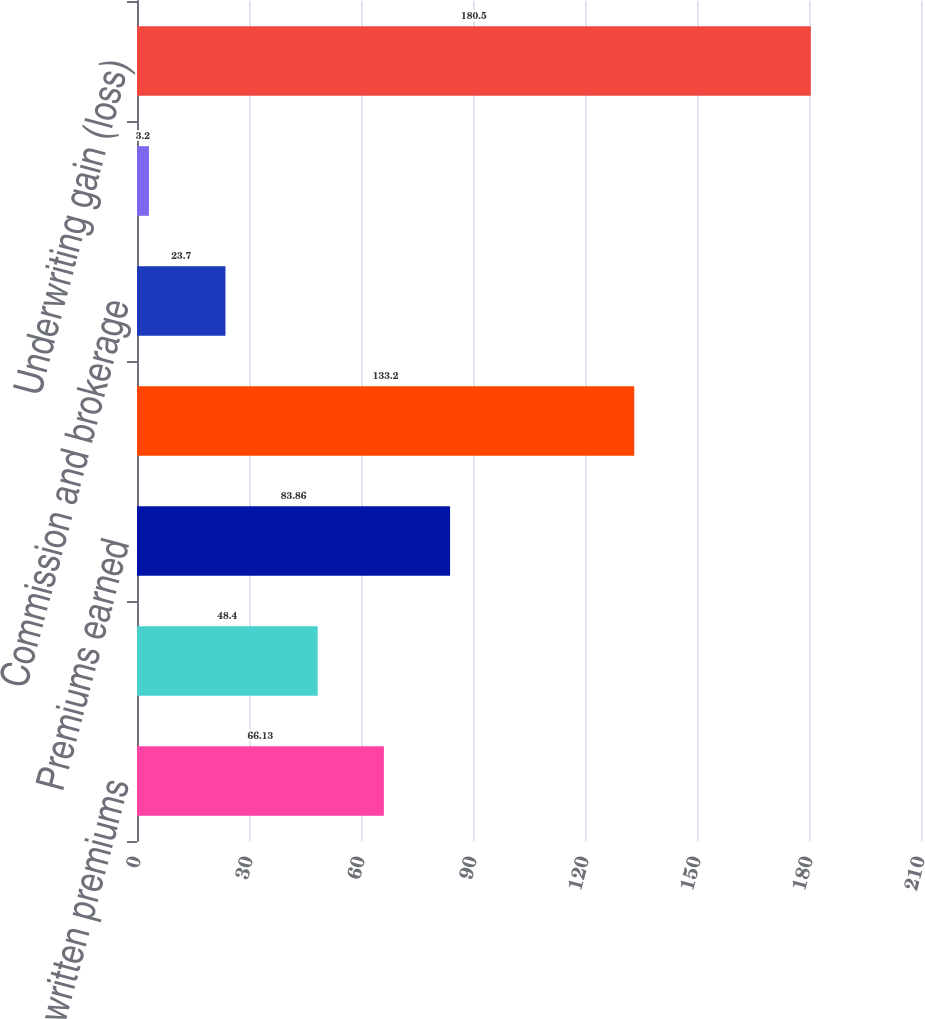Convert chart. <chart><loc_0><loc_0><loc_500><loc_500><bar_chart><fcel>Gross written premiums<fcel>Net written premiums<fcel>Premiums earned<fcel>Incurred losses and LAE<fcel>Commission and brokerage<fcel>Other underwriting expenses<fcel>Underwriting gain (loss)<nl><fcel>66.13<fcel>48.4<fcel>83.86<fcel>133.2<fcel>23.7<fcel>3.2<fcel>180.5<nl></chart> 